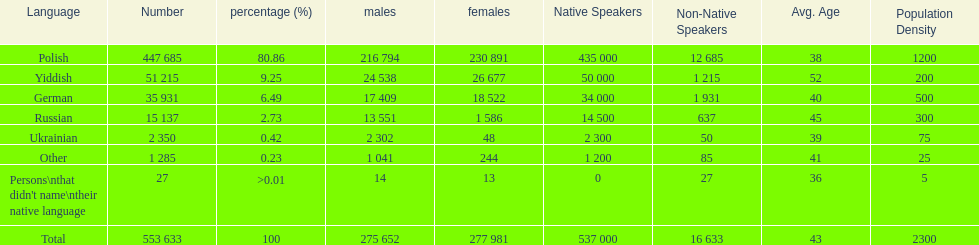How many people didn't name their native language? 27. 